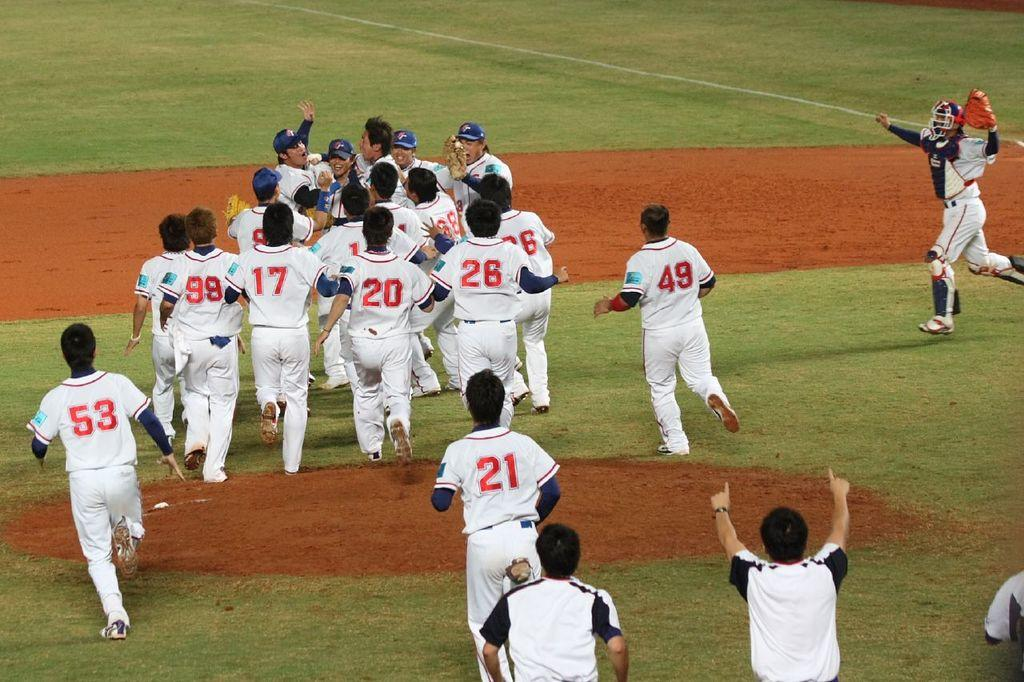<image>
Write a terse but informative summary of the picture. The player closest to the camera is number 21 